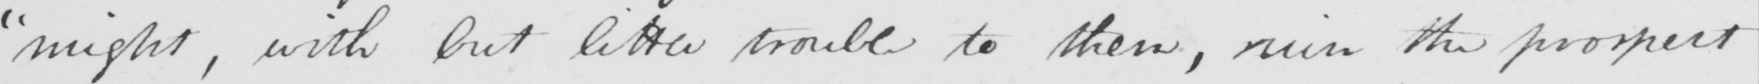Can you read and transcribe this handwriting? " might , with but little trouble to them , ruin the prospect 